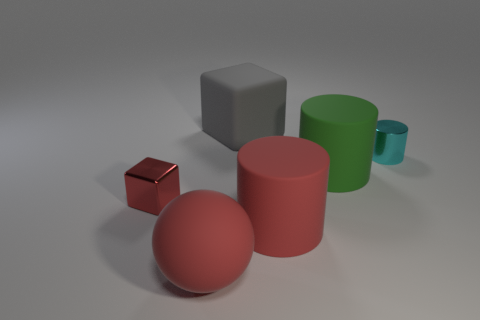Add 1 gray cubes. How many objects exist? 7 Subtract all big matte cylinders. How many cylinders are left? 1 Subtract all gray cubes. How many cubes are left? 1 Subtract all blocks. How many objects are left? 4 Subtract 1 blocks. How many blocks are left? 1 Subtract all cyan blocks. Subtract all brown cylinders. How many blocks are left? 2 Subtract all gray shiny cylinders. Subtract all green objects. How many objects are left? 5 Add 6 big gray blocks. How many big gray blocks are left? 7 Add 2 cyan shiny cubes. How many cyan shiny cubes exist? 2 Subtract 1 green cylinders. How many objects are left? 5 